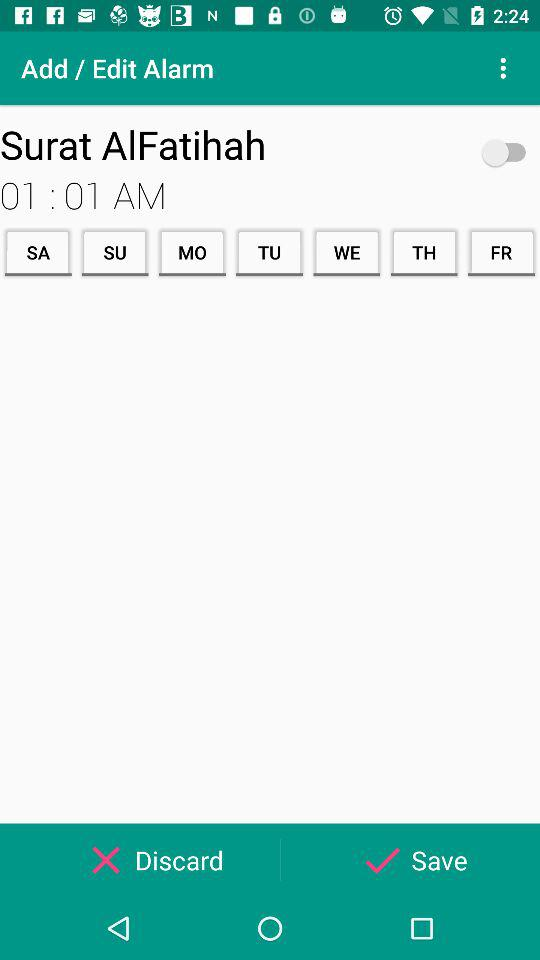What is the alarm time? The alarm time is 01:01 AM. 